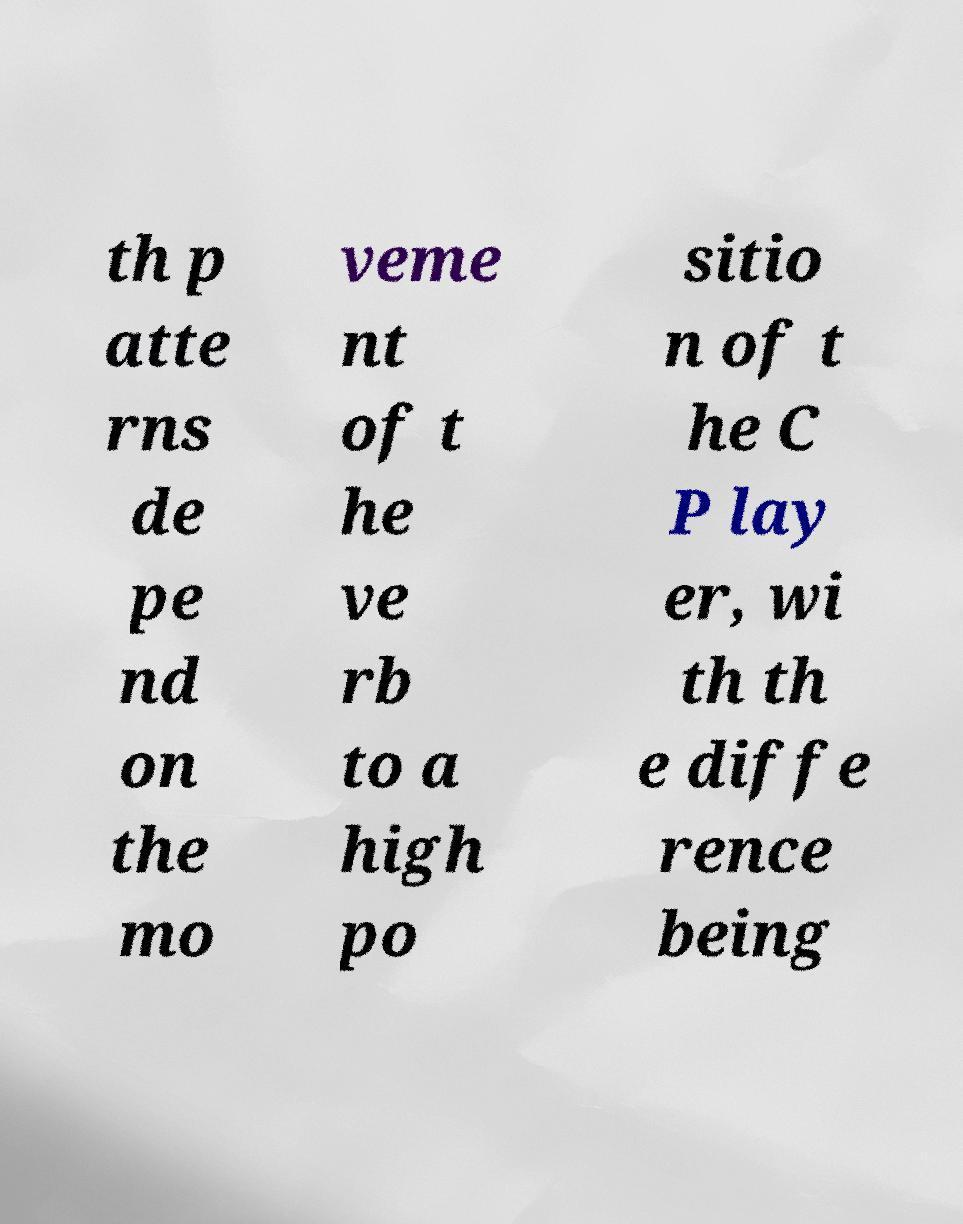Can you read and provide the text displayed in the image?This photo seems to have some interesting text. Can you extract and type it out for me? th p atte rns de pe nd on the mo veme nt of t he ve rb to a high po sitio n of t he C P lay er, wi th th e diffe rence being 